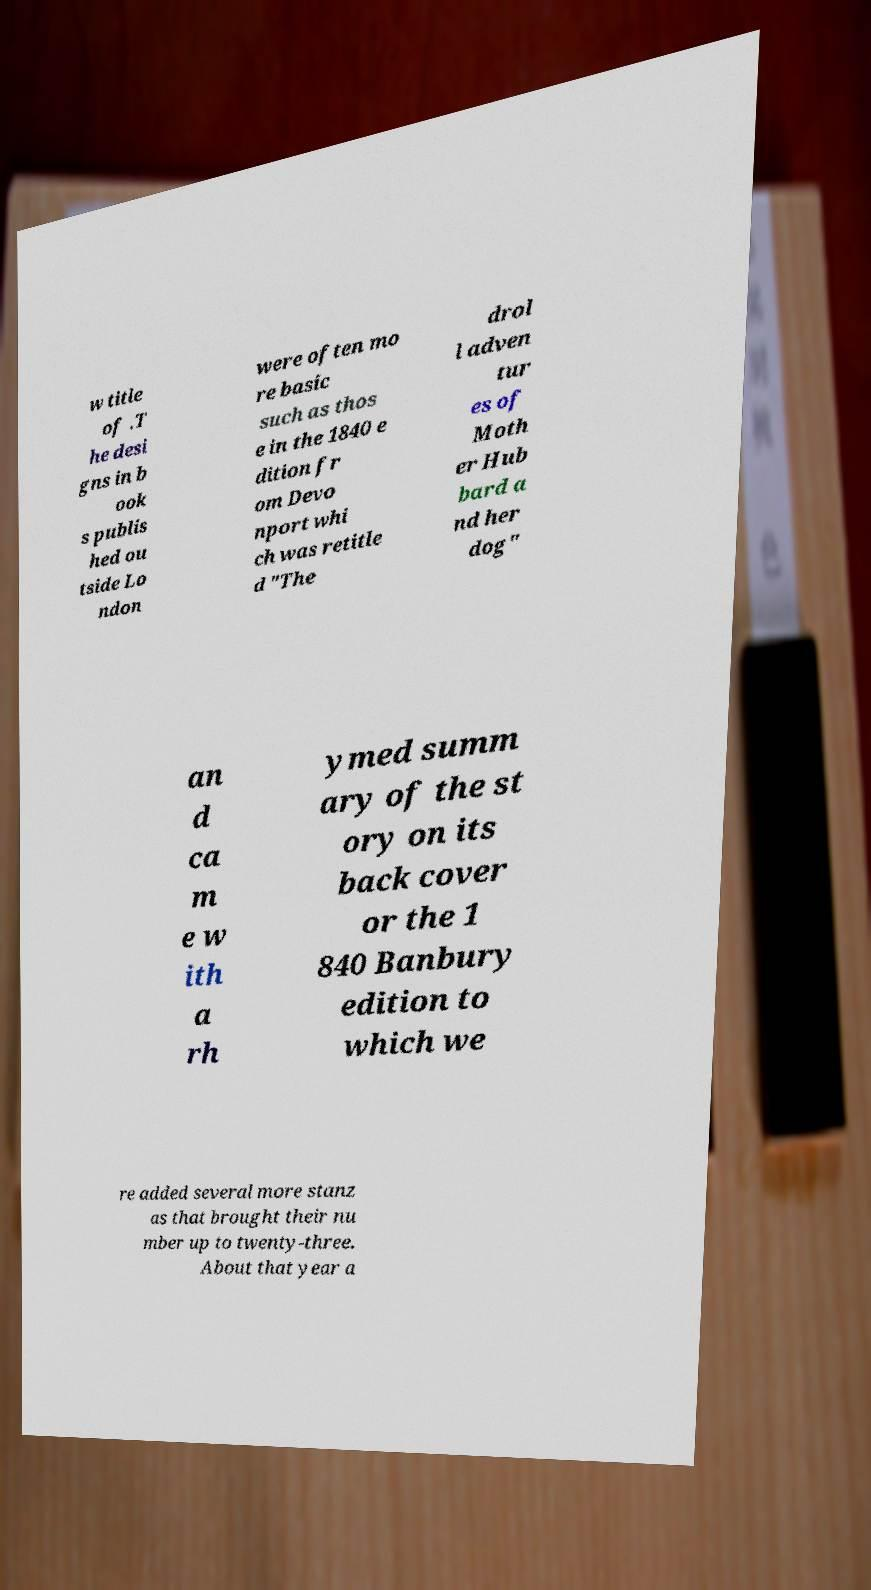Can you read and provide the text displayed in the image?This photo seems to have some interesting text. Can you extract and type it out for me? w title of .T he desi gns in b ook s publis hed ou tside Lo ndon were often mo re basic such as thos e in the 1840 e dition fr om Devo nport whi ch was retitle d "The drol l adven tur es of Moth er Hub bard a nd her dog" an d ca m e w ith a rh ymed summ ary of the st ory on its back cover or the 1 840 Banbury edition to which we re added several more stanz as that brought their nu mber up to twenty-three. About that year a 